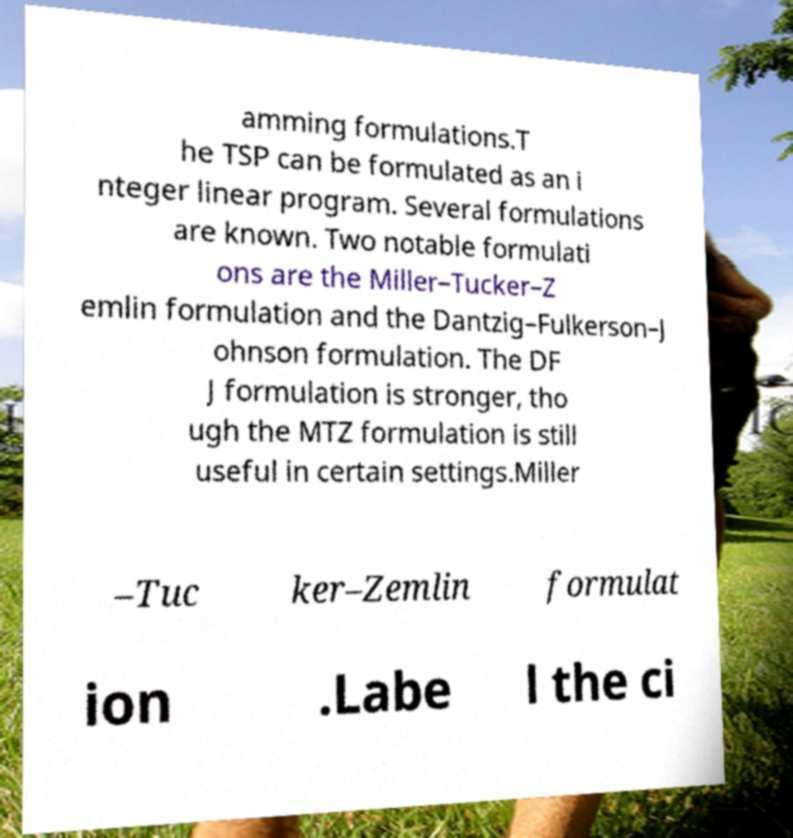Can you read and provide the text displayed in the image?This photo seems to have some interesting text. Can you extract and type it out for me? amming formulations.T he TSP can be formulated as an i nteger linear program. Several formulations are known. Two notable formulati ons are the Miller–Tucker–Z emlin formulation and the Dantzig–Fulkerson–J ohnson formulation. The DF J formulation is stronger, tho ugh the MTZ formulation is still useful in certain settings.Miller –Tuc ker–Zemlin formulat ion .Labe l the ci 